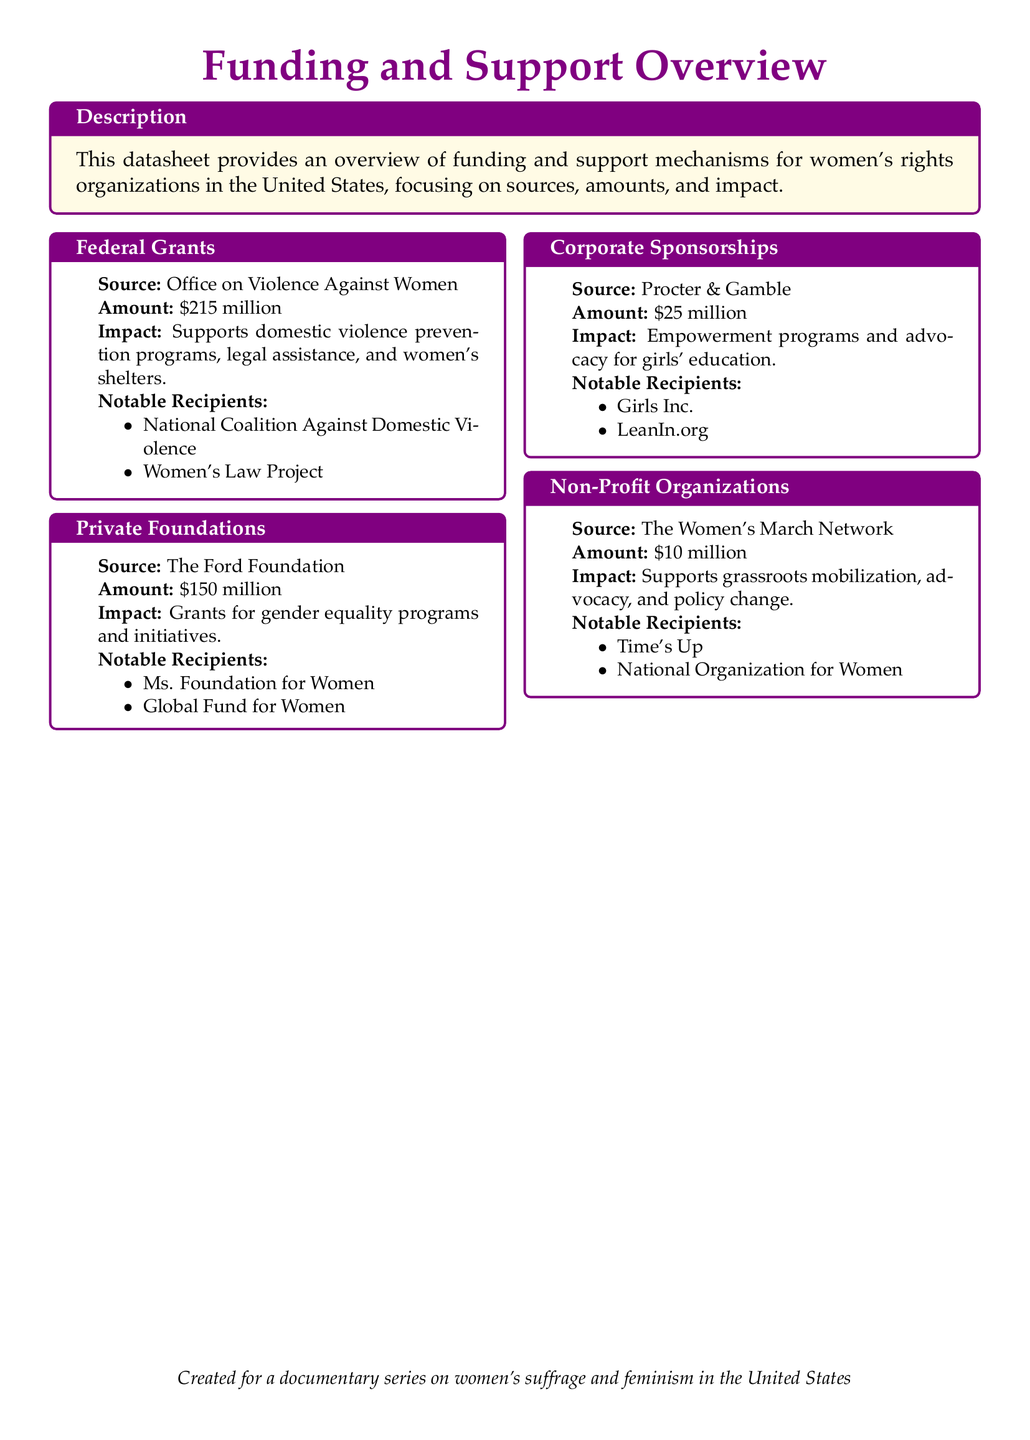what is the total amount of Federal Grants? The total amount of Federal Grants mentioned in the document is \$215 million.
Answer: \$215 million who is the source for Private Foundations? The document specifies the Ford Foundation as the source for Private Foundations.
Answer: The Ford Foundation what is the impact of Corporate Sponsorships? The document states that Corporate Sponsorships support empowerment programs and advocacy for girls' education.
Answer: Empowerment programs and advocacy for girls' education who is a notable recipient of Federal Grants? The document lists the National Coalition Against Domestic Violence as a notable recipient of Federal Grants.
Answer: National Coalition Against Domestic Violence how much funding does the Women's March Network receive? The document indicates that the Women's March Network receives \$10 million.
Answer: \$10 million what type of document is this? This document is described as a datasheet providing an overview of funding and support mechanisms for women's rights organizations.
Answer: Datasheet which organization focuses on gender equality initiatives? The document mentions the Ms. Foundation for Women as an organization that focuses on gender equality initiatives.
Answer: Ms. Foundation for Women what is the total amount of funding from Corporate Sponsorships? The document shows that the total amount of funding from Corporate Sponsorships is \$25 million.
Answer: \$25 million what is the primary source of support for domestic violence prevention programs? The primary source of support for domestic violence prevention programs is Federal Grants from the Office on Violence Against Women.
Answer: Federal Grants from the Office on Violence Against Women 